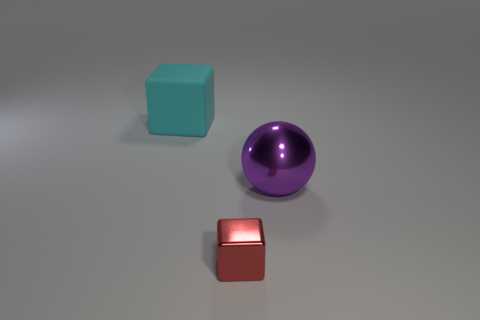Add 3 big shiny objects. How many objects exist? 6 Subtract all blocks. How many objects are left? 1 Add 2 metal blocks. How many metal blocks exist? 3 Subtract 0 blue cylinders. How many objects are left? 3 Subtract all big cyan matte things. Subtract all big cyan cubes. How many objects are left? 1 Add 2 purple metallic objects. How many purple metallic objects are left? 3 